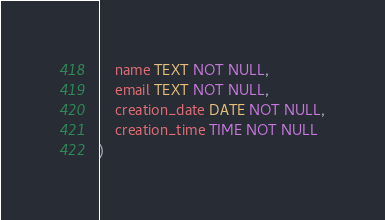<code> <loc_0><loc_0><loc_500><loc_500><_SQL_>    name TEXT NOT NULL,
    email TEXT NOT NULL,
    creation_date DATE NOT NULL,
    creation_time TIME NOT NULL
)
</code> 